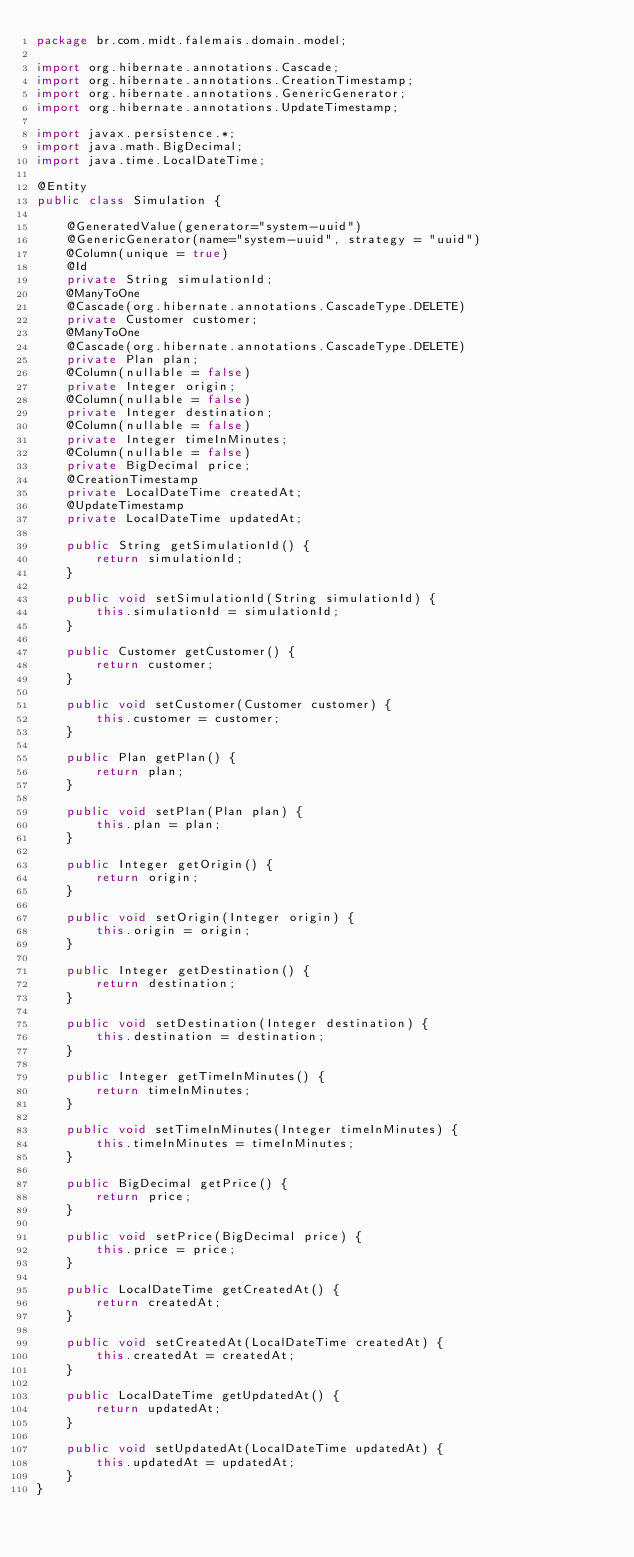Convert code to text. <code><loc_0><loc_0><loc_500><loc_500><_Java_>package br.com.midt.falemais.domain.model;

import org.hibernate.annotations.Cascade;
import org.hibernate.annotations.CreationTimestamp;
import org.hibernate.annotations.GenericGenerator;
import org.hibernate.annotations.UpdateTimestamp;

import javax.persistence.*;
import java.math.BigDecimal;
import java.time.LocalDateTime;

@Entity
public class Simulation {

    @GeneratedValue(generator="system-uuid")
    @GenericGenerator(name="system-uuid", strategy = "uuid")
    @Column(unique = true)
    @Id
    private String simulationId;
    @ManyToOne
    @Cascade(org.hibernate.annotations.CascadeType.DELETE)
    private Customer customer;
    @ManyToOne
    @Cascade(org.hibernate.annotations.CascadeType.DELETE)
    private Plan plan;
    @Column(nullable = false)
    private Integer origin;
    @Column(nullable = false)
    private Integer destination;
    @Column(nullable = false)
    private Integer timeInMinutes;
    @Column(nullable = false)
    private BigDecimal price;
    @CreationTimestamp
    private LocalDateTime createdAt;
    @UpdateTimestamp
    private LocalDateTime updatedAt;

    public String getSimulationId() {
        return simulationId;
    }

    public void setSimulationId(String simulationId) {
        this.simulationId = simulationId;
    }

    public Customer getCustomer() {
        return customer;
    }

    public void setCustomer(Customer customer) {
        this.customer = customer;
    }

    public Plan getPlan() {
        return plan;
    }

    public void setPlan(Plan plan) {
        this.plan = plan;
    }

    public Integer getOrigin() {
        return origin;
    }

    public void setOrigin(Integer origin) {
        this.origin = origin;
    }

    public Integer getDestination() {
        return destination;
    }

    public void setDestination(Integer destination) {
        this.destination = destination;
    }

    public Integer getTimeInMinutes() {
        return timeInMinutes;
    }

    public void setTimeInMinutes(Integer timeInMinutes) {
        this.timeInMinutes = timeInMinutes;
    }

    public BigDecimal getPrice() {
        return price;
    }

    public void setPrice(BigDecimal price) {
        this.price = price;
    }

    public LocalDateTime getCreatedAt() {
        return createdAt;
    }

    public void setCreatedAt(LocalDateTime createdAt) {
        this.createdAt = createdAt;
    }

    public LocalDateTime getUpdatedAt() {
        return updatedAt;
    }

    public void setUpdatedAt(LocalDateTime updatedAt) {
        this.updatedAt = updatedAt;
    }
}
</code> 